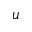Convert formula to latex. <formula><loc_0><loc_0><loc_500><loc_500>u</formula> 